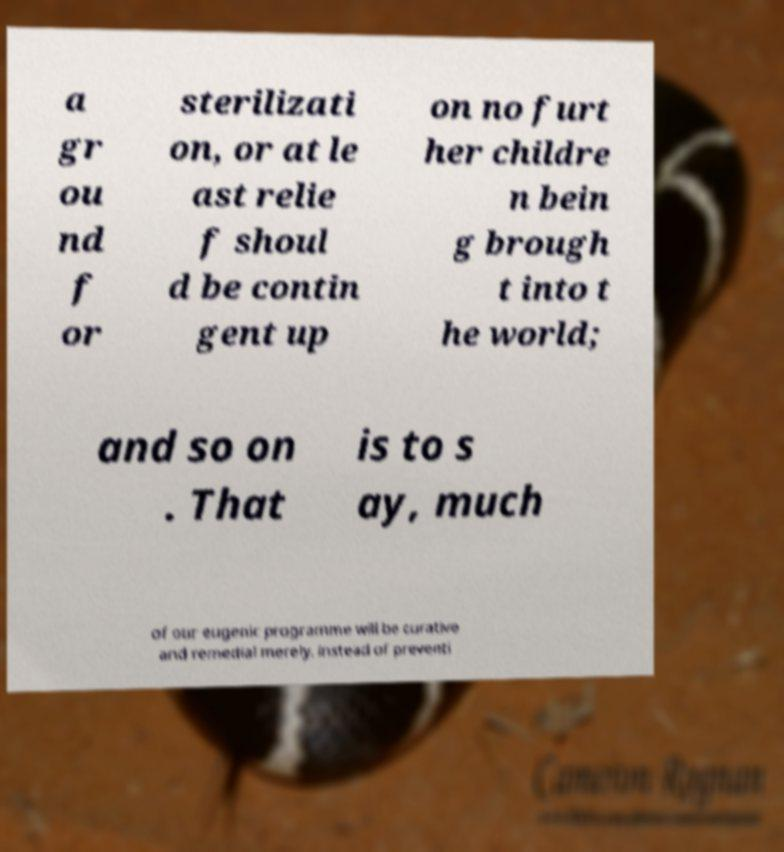For documentation purposes, I need the text within this image transcribed. Could you provide that? a gr ou nd f or sterilizati on, or at le ast relie f shoul d be contin gent up on no furt her childre n bein g brough t into t he world; and so on . That is to s ay, much of our eugenic programme will be curative and remedial merely, instead of preventi 